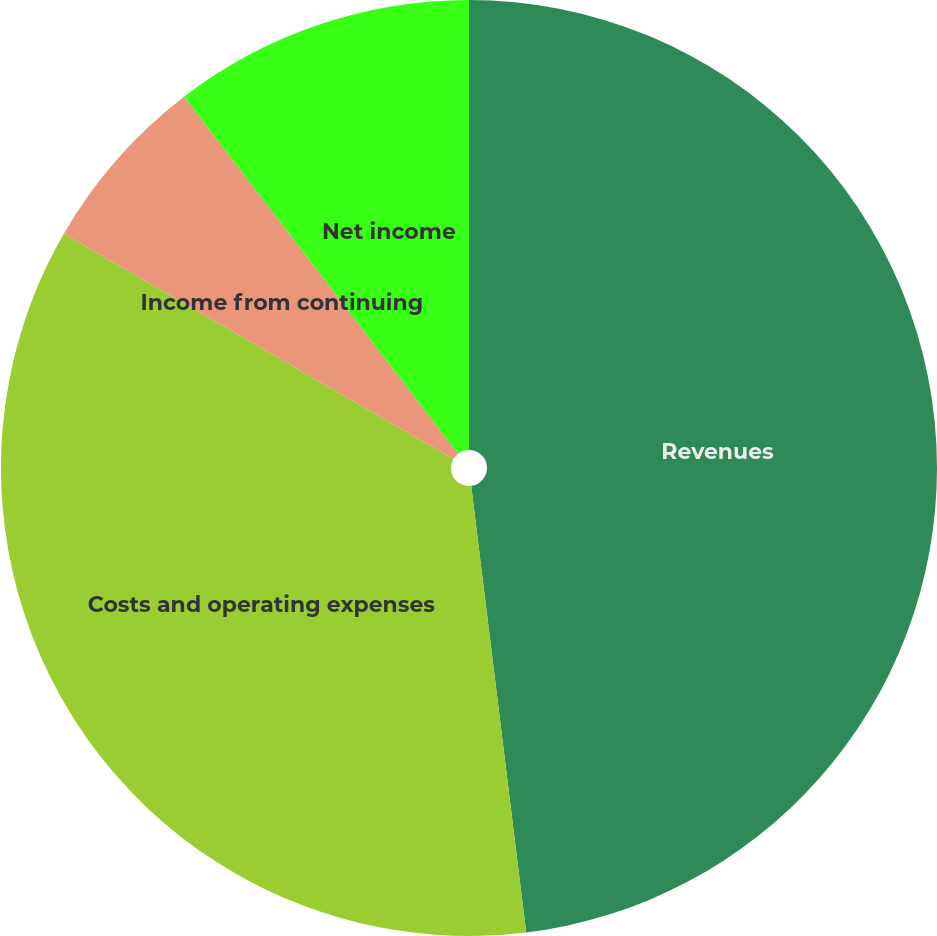<chart> <loc_0><loc_0><loc_500><loc_500><pie_chart><fcel>Revenues<fcel>Costs and operating expenses<fcel>Income from continuing<fcel>Net income<nl><fcel>48.05%<fcel>35.29%<fcel>6.24%<fcel>10.42%<nl></chart> 